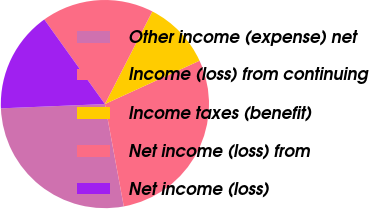Convert chart to OTSL. <chart><loc_0><loc_0><loc_500><loc_500><pie_chart><fcel>Other income (expense) net<fcel>Income (loss) from continuing<fcel>Income taxes (benefit)<fcel>Net income (loss) from<fcel>Net income (loss)<nl><fcel>27.25%<fcel>28.93%<fcel>10.63%<fcel>17.43%<fcel>15.76%<nl></chart> 